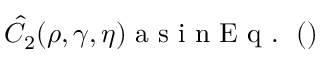Convert formula to latex. <formula><loc_0><loc_0><loc_500><loc_500>\hat { C } _ { 2 } ( \rho , \gamma , \eta ) a s i n E q . ( )</formula> 